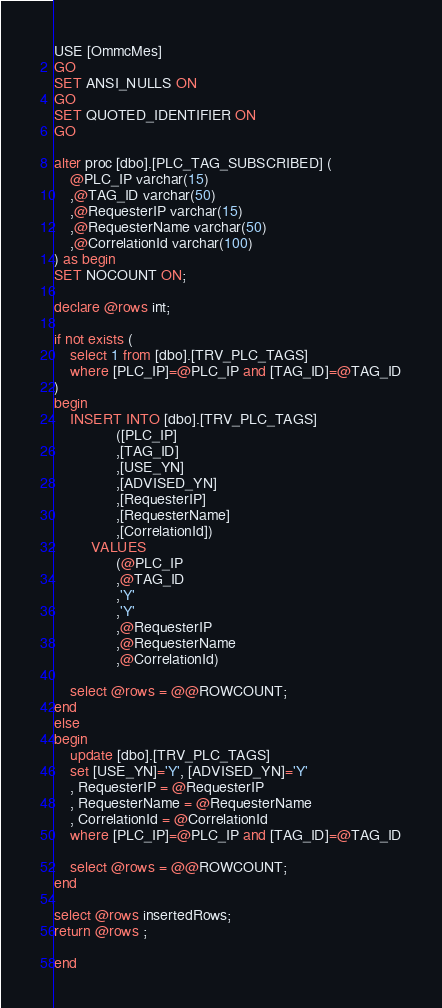<code> <loc_0><loc_0><loc_500><loc_500><_SQL_>USE [OmmcMes]
GO
SET ANSI_NULLS ON
GO
SET QUOTED_IDENTIFIER ON
GO

alter proc [dbo].[PLC_TAG_SUBSCRIBED] (
	@PLC_IP varchar(15) 
	,@TAG_ID varchar(50) 
	,@RequesterIP varchar(15) 
	,@RequesterName varchar(50) 
	,@CorrelationId varchar(100) 
) as begin
SET NOCOUNT ON;

declare @rows int;

if not exists (
	select 1 from [dbo].[TRV_PLC_TAGS]
	where [PLC_IP]=@PLC_IP and [TAG_ID]=@TAG_ID
)
begin
	INSERT INTO [dbo].[TRV_PLC_TAGS]
			   ([PLC_IP]
			   ,[TAG_ID]
			   ,[USE_YN]
			   ,[ADVISED_YN]
			   ,[RequesterIP]
			   ,[RequesterName]
			   ,[CorrelationId])
		 VALUES
			   (@PLC_IP
			   ,@TAG_ID
			   ,'Y'
			   ,'Y'
			   ,@RequesterIP
			   ,@RequesterName
			   ,@CorrelationId)

	select @rows = @@ROWCOUNT;
end
else
begin
	update [dbo].[TRV_PLC_TAGS]
	set [USE_YN]='Y', [ADVISED_YN]='Y'
	, RequesterIP = @RequesterIP
	, RequesterName = @RequesterName
	, CorrelationId = @CorrelationId
	where [PLC_IP]=@PLC_IP and [TAG_ID]=@TAG_ID

	select @rows = @@ROWCOUNT;
end

select @rows insertedRows;
return @rows ;

end

</code> 